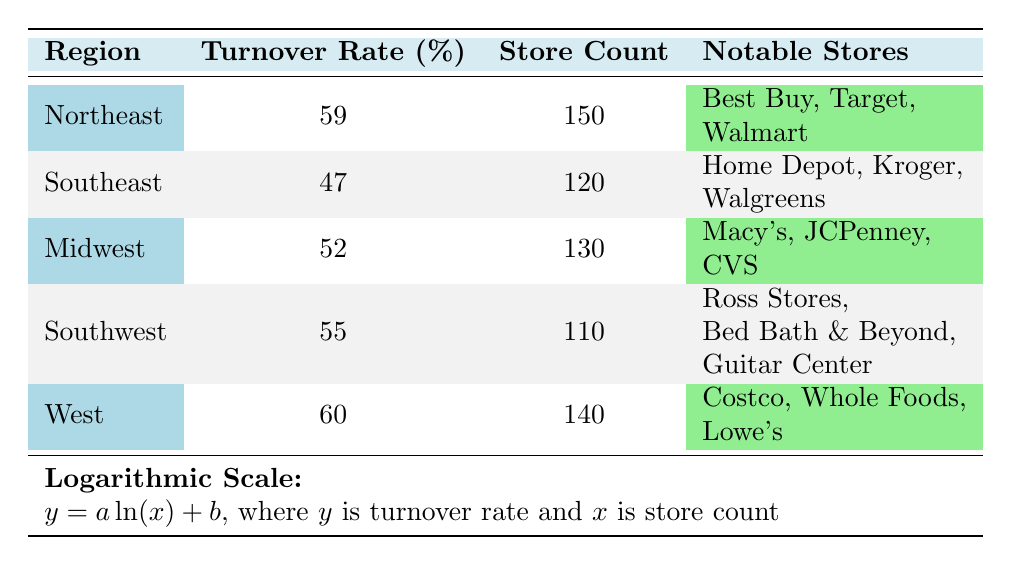What is the average turnover rate for the Northeast region? The table lists the average turnover rate for the Northeast region as 59%.
Answer: 59% Which region has the lowest average turnover rate? By examining the table, the Southeast region shows an average turnover rate of 47%, which is lower than all other regions.
Answer: Southeast How many notable stores are listed for the Midwest region? The Midwest region has three notable stores: Macy's, JCPenney, and CVS, which can be confirmed by reviewing the notable stores column for that region.
Answer: 3 What is the difference in average turnover rate between the West and Southeast regions? The West region has an average turnover rate of 60%, while the Southeast has 47%. The difference is calculated as 60 - 47 = 13.
Answer: 13 Is it true that the Southwest region has more stores than the Southeast region? The Southwest region has 110 stores, while the Southeast has 120 stores. Therefore, it is false that the Southwest has more stores.
Answer: No What is the total number of stores in the Northeast and Southwest regions combined? The Northeast region has 150 stores and the Southwest has 110. Adding these together gives 150 + 110 = 260.
Answer: 260 Which region has notable stores listed as 'Home Depot, Kroger, Walgreens'? These notable stores belong to the Southeast region, as indicated in the notable stores column for that region.
Answer: Southeast If average turnover rates were to be ranked, what would be the rank of the Midwest region? The average turnover rates in descending order are: West (60), Northeast (59), Southwest (55), Midwest (52), and Southeast (47). Hence, the Midwest is ranked 4th among the 5 regions.
Answer: 4th 